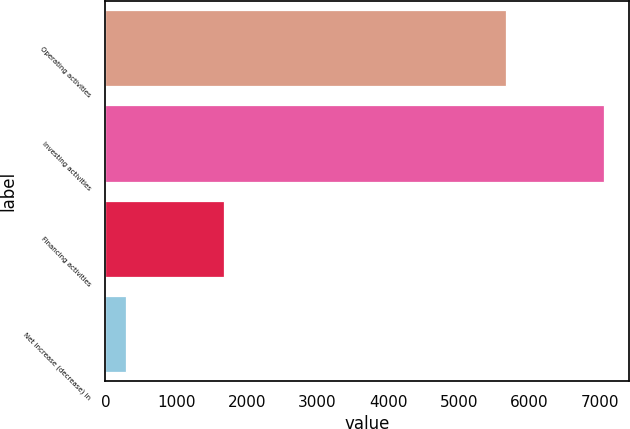Convert chart to OTSL. <chart><loc_0><loc_0><loc_500><loc_500><bar_chart><fcel>Operating activities<fcel>Investing activities<fcel>Financing activities<fcel>Net increase (decrease) in<nl><fcel>5660<fcel>7051<fcel>1682<fcel>291<nl></chart> 